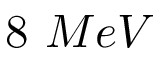<formula> <loc_0><loc_0><loc_500><loc_500>8 M e V</formula> 